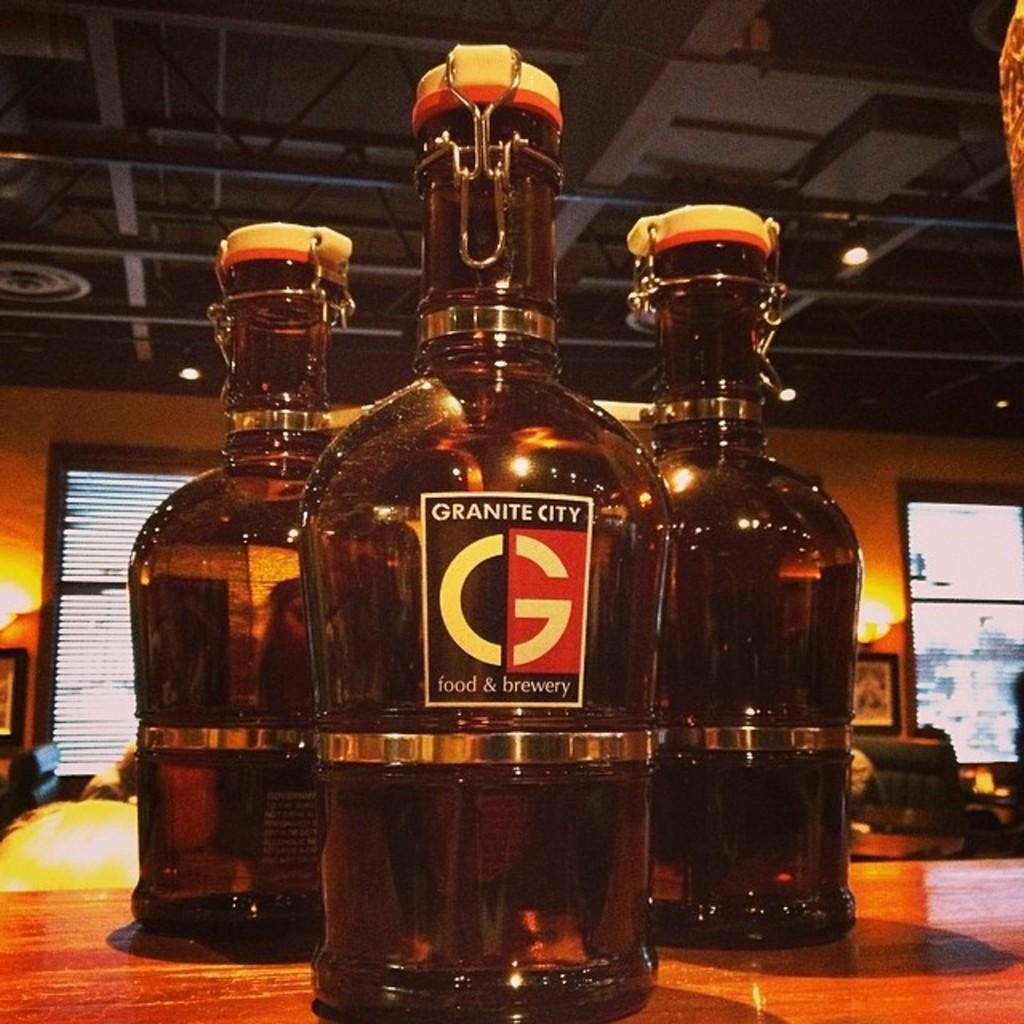<image>
Create a compact narrative representing the image presented. A jug of Granite City sits in front of two other jugs. 